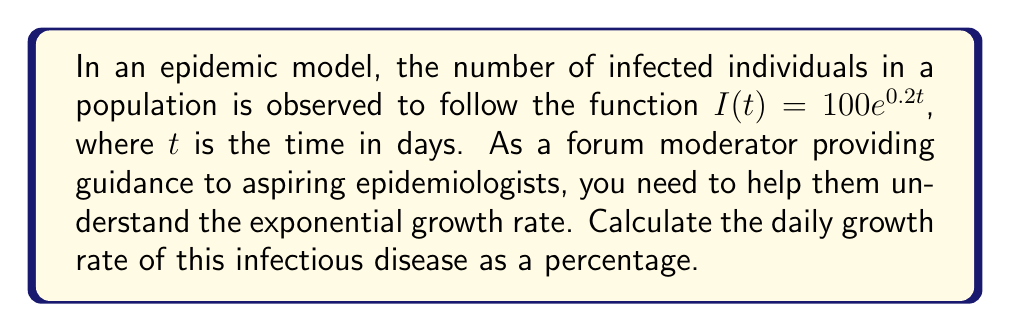Can you answer this question? To determine the daily growth rate of the infectious disease, we need to analyze the given function:

$I(t) = 100e^{0.2t}$

This function is in the form of exponential growth, where:
- $100$ is the initial number of infected individuals
- $e$ is Euler's number (approximately 2.71828)
- $0.2$ is the growth rate coefficient
- $t$ is the time in days

To calculate the daily growth rate as a percentage:

1. Consider the change over one day by comparing $I(t+1)$ to $I(t)$:

   $\frac{I(t+1)}{I(t)} = \frac{100e^{0.2(t+1)}}{100e^{0.2t}}$

2. Simplify:

   $\frac{I(t+1)}{I(t)} = \frac{e^{0.2t} \cdot e^{0.2}}{e^{0.2t}} = e^{0.2}$

3. Calculate $e^{0.2}$:

   $e^{0.2} \approx 1.2214$

4. To express this as a percentage increase, subtract 1 and multiply by 100:

   $(e^{0.2} - 1) \times 100\% \approx (1.2214 - 1) \times 100\% \approx 22.14\%$

This means the number of infected individuals increases by approximately 22.14% each day.
Answer: The daily growth rate of the infectious disease is approximately 22.14%. 